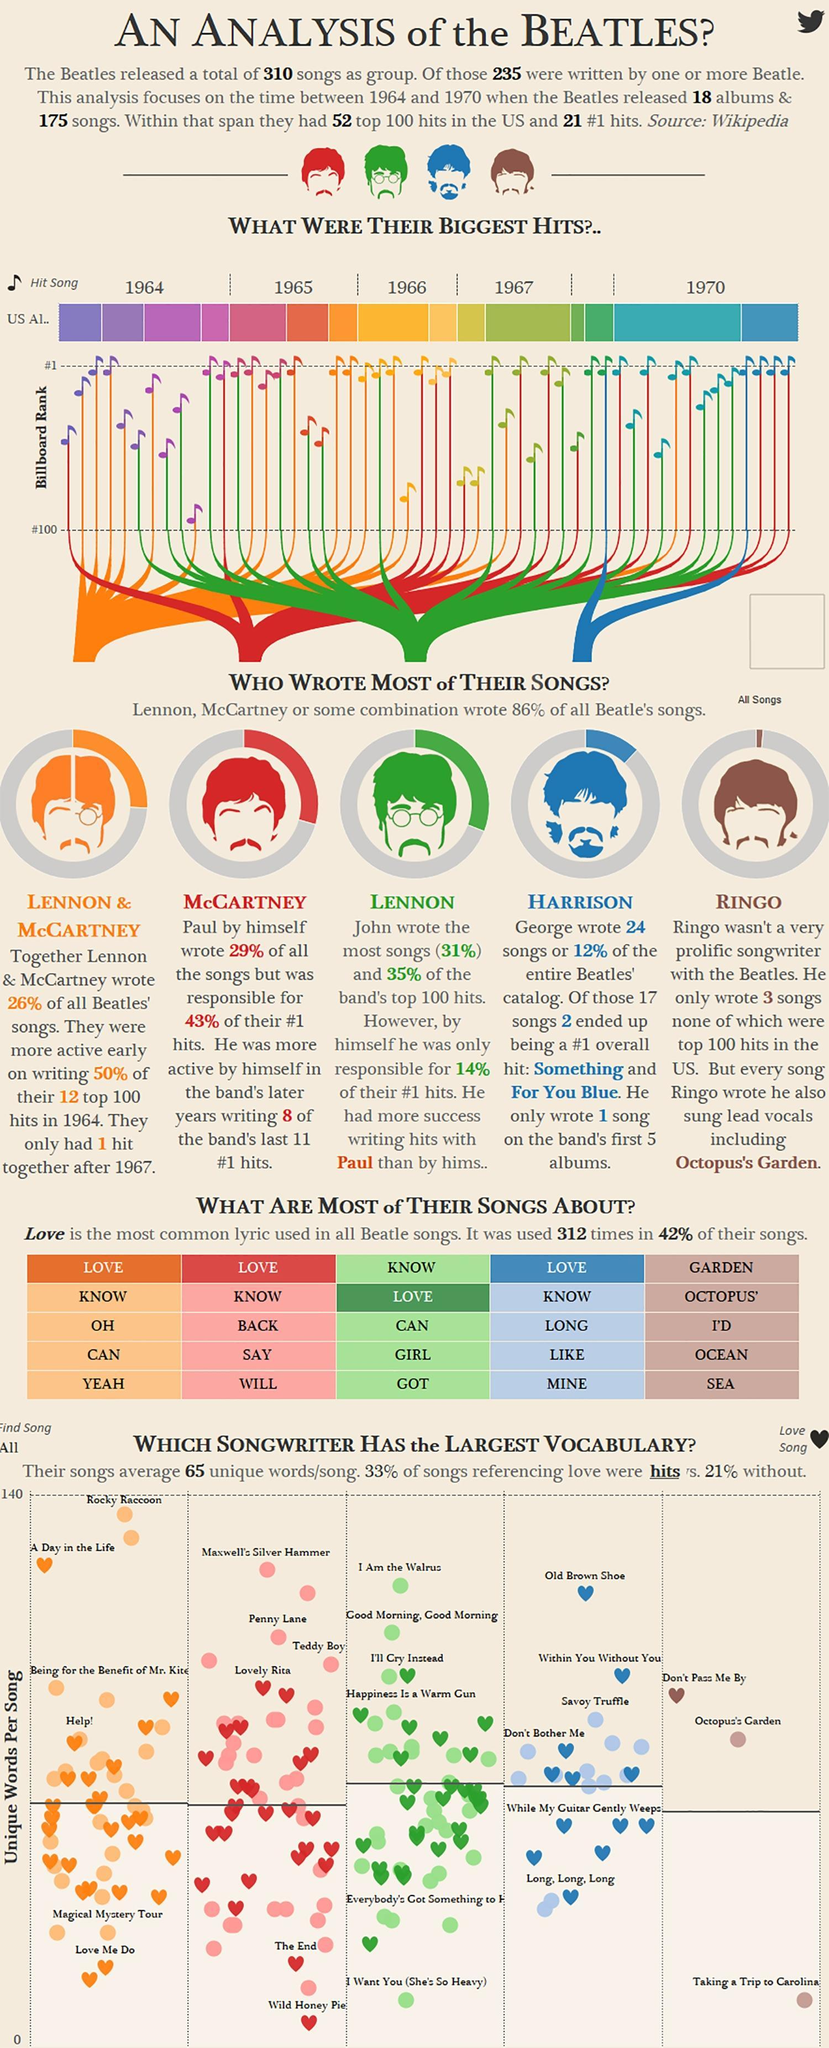How many songs were written by Harrison?
Answer the question with a short phrase. 24 What percent of the band's songs was written by Lennon & McCartney together? 26% Who wrote the song Octopus's Garden? Ringo Who wrote the lowest number of songs? Ringo 